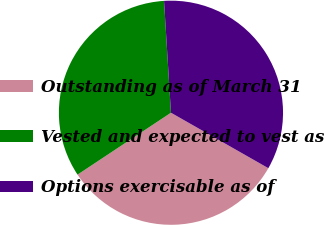Convert chart. <chart><loc_0><loc_0><loc_500><loc_500><pie_chart><fcel>Outstanding as of March 31<fcel>Vested and expected to vest as<fcel>Options exercisable as of<nl><fcel>32.44%<fcel>33.33%<fcel>34.22%<nl></chart> 